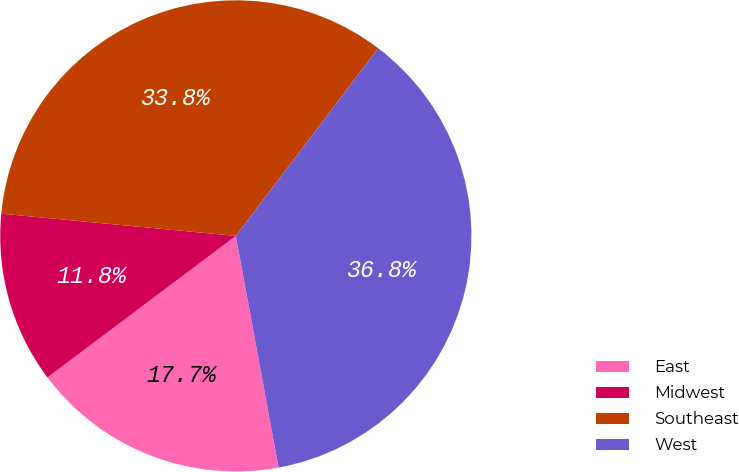<chart> <loc_0><loc_0><loc_500><loc_500><pie_chart><fcel>East<fcel>Midwest<fcel>Southeast<fcel>West<nl><fcel>17.65%<fcel>11.76%<fcel>33.82%<fcel>36.76%<nl></chart> 